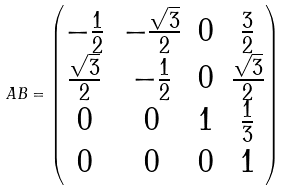<formula> <loc_0><loc_0><loc_500><loc_500>A B = \begin{pmatrix} - \frac { 1 } { 2 } & - \frac { \sqrt { 3 } } { 2 } & 0 & \frac { 3 } { 2 } \\ \frac { \sqrt { 3 } } { 2 } & - \frac { 1 } { 2 } & 0 & \frac { \sqrt { 3 } } { 2 } \\ 0 & 0 & 1 & \frac { 1 } { 3 } \\ 0 & 0 & 0 & 1 \end{pmatrix}</formula> 